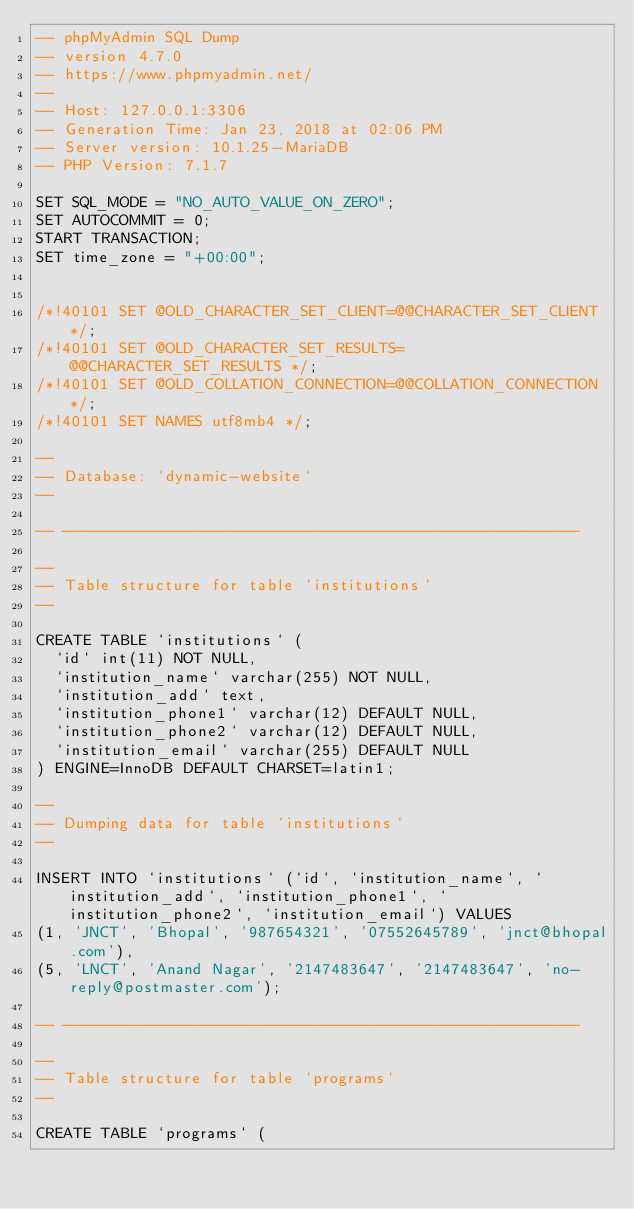<code> <loc_0><loc_0><loc_500><loc_500><_SQL_>-- phpMyAdmin SQL Dump
-- version 4.7.0
-- https://www.phpmyadmin.net/
--
-- Host: 127.0.0.1:3306
-- Generation Time: Jan 23, 2018 at 02:06 PM
-- Server version: 10.1.25-MariaDB
-- PHP Version: 7.1.7

SET SQL_MODE = "NO_AUTO_VALUE_ON_ZERO";
SET AUTOCOMMIT = 0;
START TRANSACTION;
SET time_zone = "+00:00";


/*!40101 SET @OLD_CHARACTER_SET_CLIENT=@@CHARACTER_SET_CLIENT */;
/*!40101 SET @OLD_CHARACTER_SET_RESULTS=@@CHARACTER_SET_RESULTS */;
/*!40101 SET @OLD_COLLATION_CONNECTION=@@COLLATION_CONNECTION */;
/*!40101 SET NAMES utf8mb4 */;

--
-- Database: `dynamic-website`
--

-- --------------------------------------------------------

--
-- Table structure for table `institutions`
--

CREATE TABLE `institutions` (
  `id` int(11) NOT NULL,
  `institution_name` varchar(255) NOT NULL,
  `institution_add` text,
  `institution_phone1` varchar(12) DEFAULT NULL,
  `institution_phone2` varchar(12) DEFAULT NULL,
  `institution_email` varchar(255) DEFAULT NULL
) ENGINE=InnoDB DEFAULT CHARSET=latin1;

--
-- Dumping data for table `institutions`
--

INSERT INTO `institutions` (`id`, `institution_name`, `institution_add`, `institution_phone1`, `institution_phone2`, `institution_email`) VALUES
(1, 'JNCT', 'Bhopal', '987654321', '07552645789', 'jnct@bhopal.com'),
(5, 'LNCT', 'Anand Nagar', '2147483647', '2147483647', 'no-reply@postmaster.com');

-- --------------------------------------------------------

--
-- Table structure for table `programs`
--

CREATE TABLE `programs` (</code> 